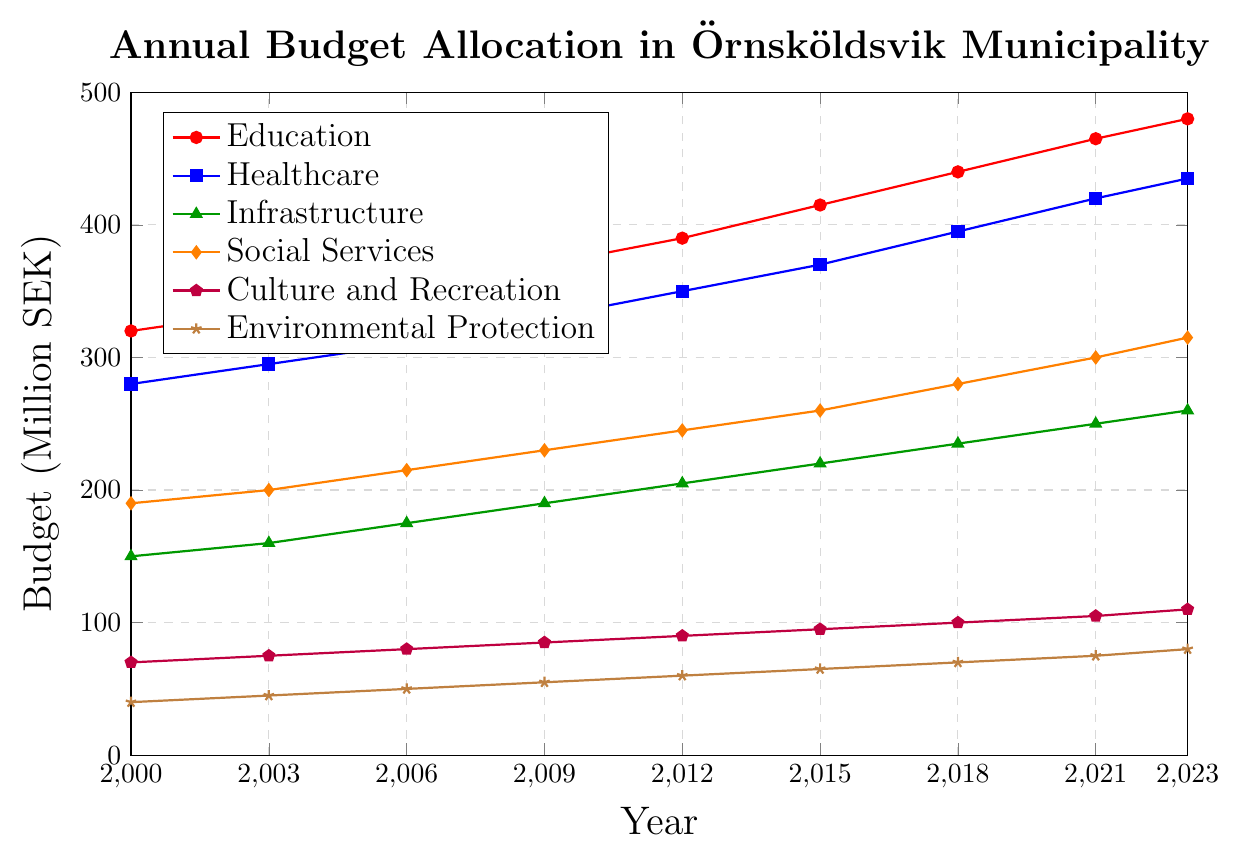Which sector had the highest budget allocation in 2023? By looking at the data points on the graph for 2023, observe the highest value plotted. The "Education" sector has the highest value of 480 million SEK in 2023.
Answer: Education By how much did the budget for Healthcare increase from 2000 to 2023? Observe the budget values for Healthcare in 2000 (280 million SEK) and 2023 (435 million SEK). Subtract the 2000 value from the 2023 value (435 - 280).
Answer: 155 million SEK Which sector experienced the largest percentage increase in budget allocation from 2000 to 2023? First, calculate the percentage increase for each sector using the formula: (final value - initial value) / initial value * 100. Education: (480-320) / 320 * 100 = 50%, Healthcare: (435-280) / 280 * 100 = 55.36%, Infrastructure: (260-150) / 150 * 100 = 73.33%, Social Services: (315-190) / 190 * 100 = 65.79%, Culture and Recreation: (110-70) / 70 * 100 = 57.14%, Environmental Protection: (80-40) / 40 * 100 = 100%. The largest percentage increase is for Environmental Protection.
Answer: Environmental Protection In which years did the Social Services budget exceed the Infrastructure budget by at least 50 million SEK? Compare the data points of Social Services and Infrastructure for each year. For 2015 (260 - 220 = 40, not enough), 2018 (280 - 235 = 45, not enough), 2021 (300 - 250 = 50, enough), and 2023 (315 - 260 = 55, enough). The years are 2021 and 2023.
Answer: 2021, 2023 Which sector has the steadiest increase in budget allocation over the years, and how can you tell? By visually analyzing the graphs' slopes, the line with the most uniform upward trajectory represents the steadiest increase. The Healthcare sector shows the most consistent increment each year without significant fluctuations or variations in the increase rate.
Answer: Healthcare 